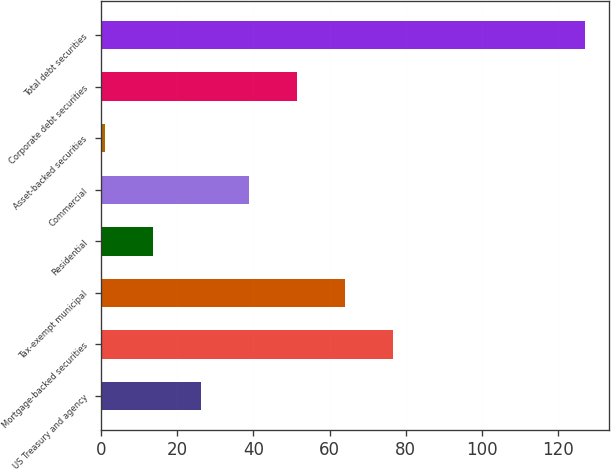Convert chart. <chart><loc_0><loc_0><loc_500><loc_500><bar_chart><fcel>US Treasury and agency<fcel>Mortgage-backed securities<fcel>Tax-exempt municipal<fcel>Residential<fcel>Commercial<fcel>Asset-backed securities<fcel>Corporate debt securities<fcel>Total debt securities<nl><fcel>26.2<fcel>76.6<fcel>64<fcel>13.6<fcel>38.8<fcel>1<fcel>51.4<fcel>127<nl></chart> 